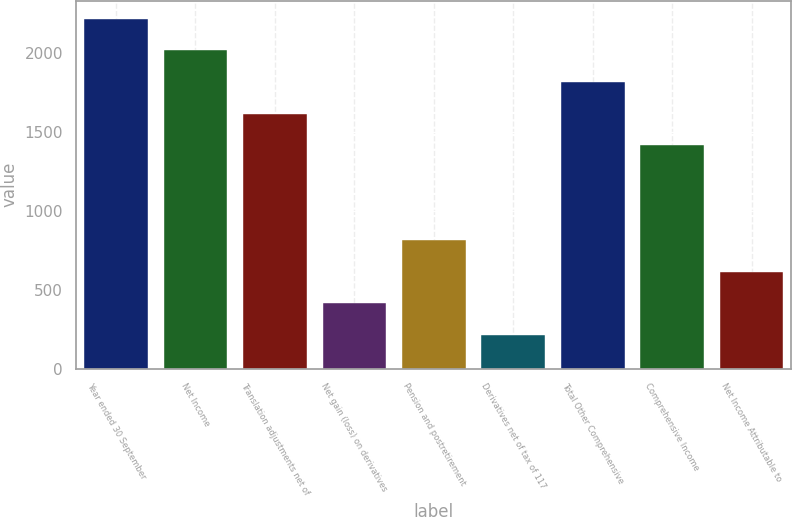Convert chart. <chart><loc_0><loc_0><loc_500><loc_500><bar_chart><fcel>Year ended 30 September<fcel>Net Income<fcel>Translation adjustments net of<fcel>Net gain (loss) on derivatives<fcel>Pension and postretirement<fcel>Derivatives net of tax of 117<fcel>Total Other Comprehensive<fcel>Comprehensive Income<fcel>Net Income Attributable to<nl><fcel>2215.4<fcel>2015<fcel>1614.2<fcel>411.8<fcel>812.6<fcel>211.4<fcel>1814.6<fcel>1413.8<fcel>612.2<nl></chart> 